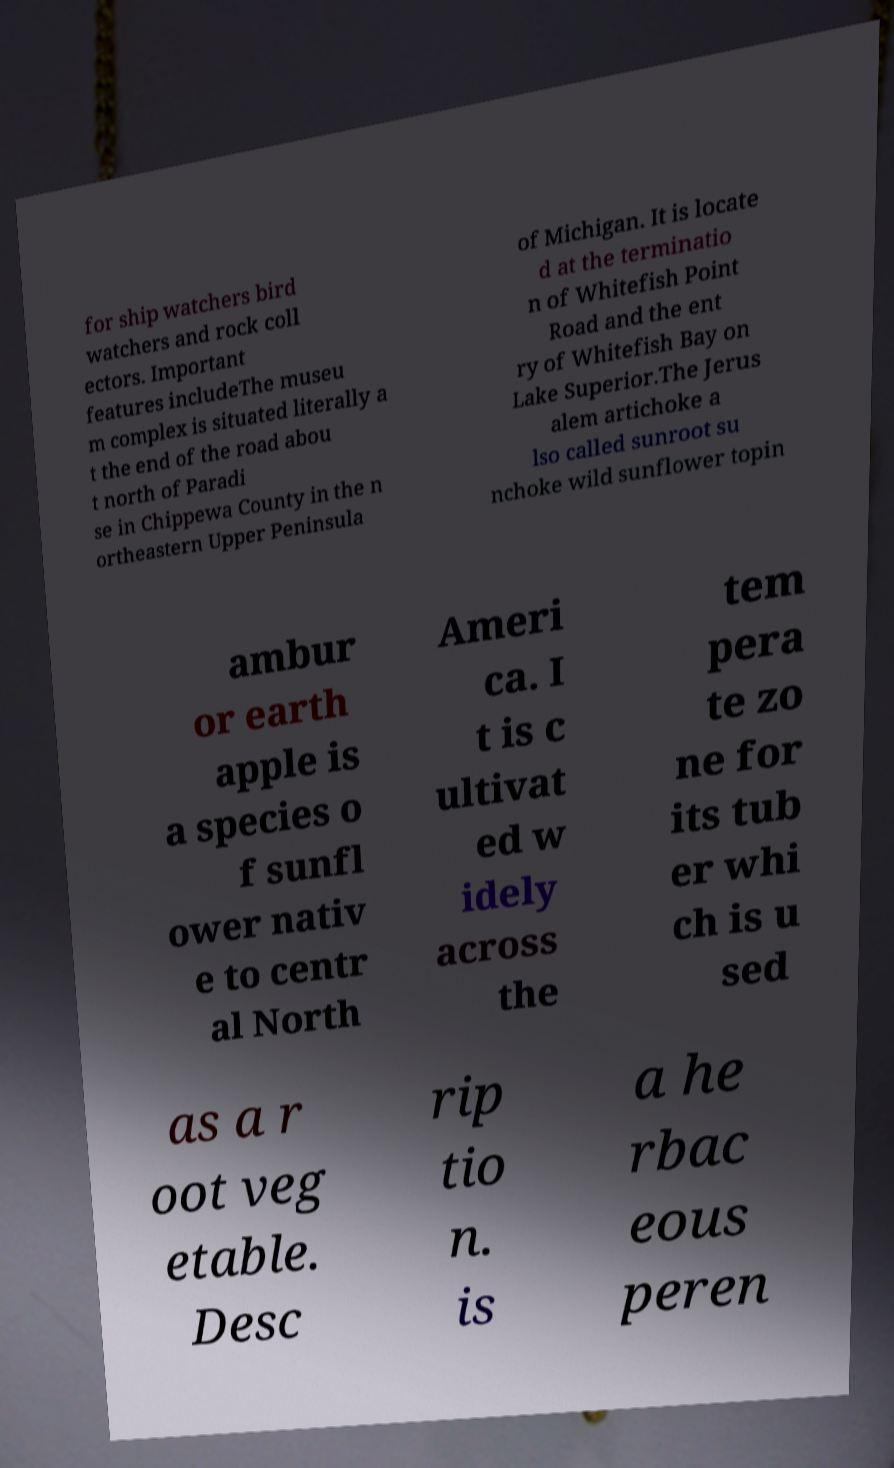Can you read and provide the text displayed in the image?This photo seems to have some interesting text. Can you extract and type it out for me? for ship watchers bird watchers and rock coll ectors. Important features includeThe museu m complex is situated literally a t the end of the road abou t north of Paradi se in Chippewa County in the n ortheastern Upper Peninsula of Michigan. It is locate d at the terminatio n of Whitefish Point Road and the ent ry of Whitefish Bay on Lake Superior.The Jerus alem artichoke a lso called sunroot su nchoke wild sunflower topin ambur or earth apple is a species o f sunfl ower nativ e to centr al North Ameri ca. I t is c ultivat ed w idely across the tem pera te zo ne for its tub er whi ch is u sed as a r oot veg etable. Desc rip tio n. is a he rbac eous peren 